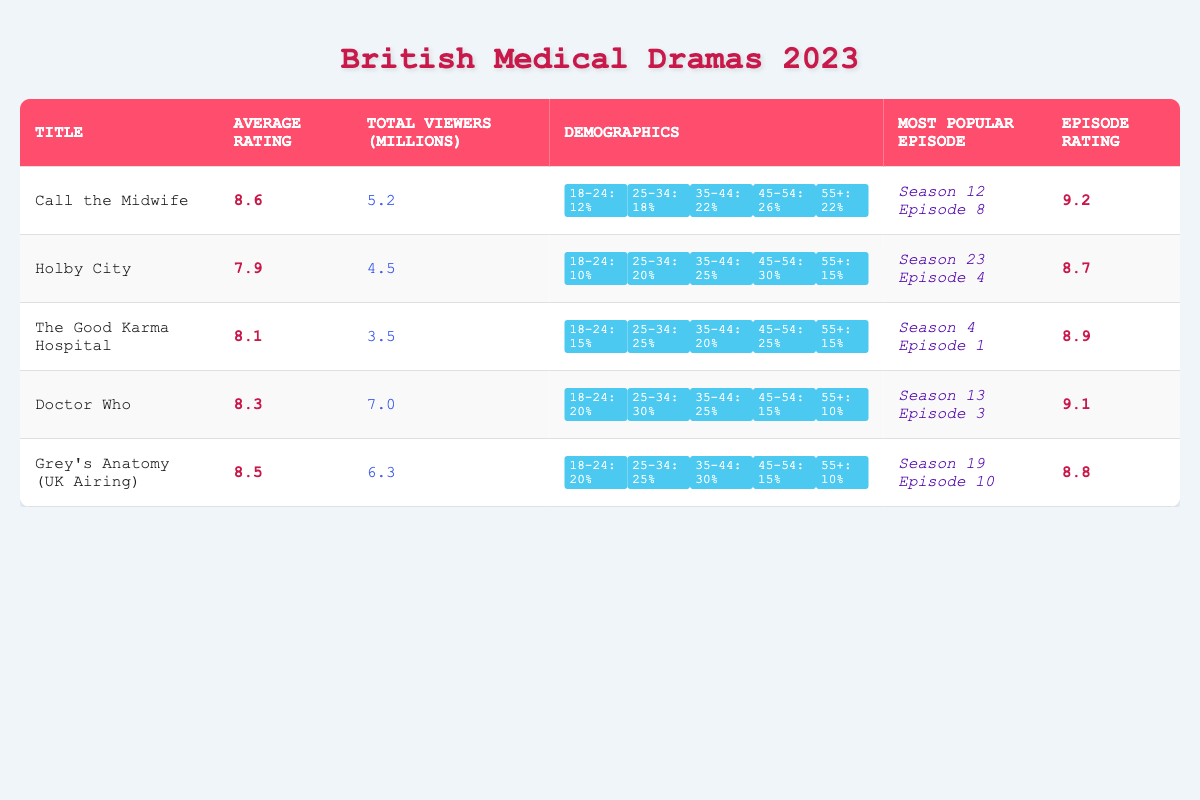What is the average rating of "Call the Midwife"? The average rating for "Call the Midwife" is clearly stated in the table as 8.6.
Answer: 8.6 Which show had the highest total viewers in millions? By comparing the total viewers' numbers, "Doctor Who" with 7.0 million viewers has the highest total viewers among the listed shows.
Answer: Doctor Who What is the age demographic percentage for the 45-54 age group in "Holby City"? The table lists the percentage of the 45-54 age demographic for "Holby City" as 30%.
Answer: 30% How many total viewers did "Grey's Anatomy (UK Airing)" have compared to "The Good Karma Hospital"? "Grey's Anatomy (UK Airing)" had 6.3 million viewers, while "The Good Karma Hospital" had 3.5 million viewers. The difference is 6.3 - 3.5 = 2.8 million viewers.
Answer: 2.8 million more viewers What percentage of the audience for "Doctor Who" is aged 18-24? The percentage of the audience for "Doctor Who" in the 18-24 demographic is recorded in the table as 20%.
Answer: 20% Which show has the lowest average rating, and what is that rating? By reviewing the average ratings, "Holby City" has the lowest average rating of 7.9.
Answer: Holby City, 7.9 If we sum the ratings for "Call the Midwife" and "The Good Karma Hospital," what is the total? The ratings to sum are 8.6 (Call the Midwife) + 8.1 (The Good Karma Hospital) = 16.7.
Answer: 16.7 Is "Doctor Who" more popular than "Holby City" based on total viewers? "Doctor Who" has 7.0 million viewers while "Holby City" has 4.5 million viewers, making "Doctor Who" more popular.
Answer: Yes What is the average age demographic percentage for the 25-34 age group across all medical dramas? The percentages for the 25-34 demographic are: Call the Midwife (18%), Holby City (20%), The Good Karma Hospital (25%), Doctor Who (30%), Grey's Anatomy (25%). The average is (18 + 20 + 25 + 30 + 25) / 5 = 23.6%.
Answer: 23.6% How does the most popular episode rating of "Grey's Anatomy (UK Airing)" compare to "Call the Midwife"? The most popular episode rating for "Grey's Anatomy (UK Airing)" is 8.8, while for "Call the Midwife," it is 9.2. Since 9.2 > 8.8, "Call the Midwife" has a higher rating.
Answer: Call the Midwife is higher Which show has the largest age demographic percentage for the 35-44 age group? By checking the table, "Grey's Anatomy (UK Airing)" and "Holby City" both have the highest percentage for the 35-44 age group at 30%.
Answer: Both Grey's Anatomy (UK Airing) and Holby City at 30% 